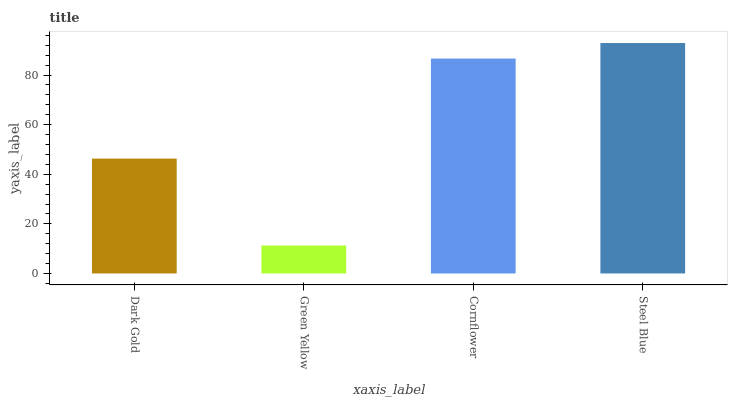Is Green Yellow the minimum?
Answer yes or no. Yes. Is Steel Blue the maximum?
Answer yes or no. Yes. Is Cornflower the minimum?
Answer yes or no. No. Is Cornflower the maximum?
Answer yes or no. No. Is Cornflower greater than Green Yellow?
Answer yes or no. Yes. Is Green Yellow less than Cornflower?
Answer yes or no. Yes. Is Green Yellow greater than Cornflower?
Answer yes or no. No. Is Cornflower less than Green Yellow?
Answer yes or no. No. Is Cornflower the high median?
Answer yes or no. Yes. Is Dark Gold the low median?
Answer yes or no. Yes. Is Dark Gold the high median?
Answer yes or no. No. Is Steel Blue the low median?
Answer yes or no. No. 